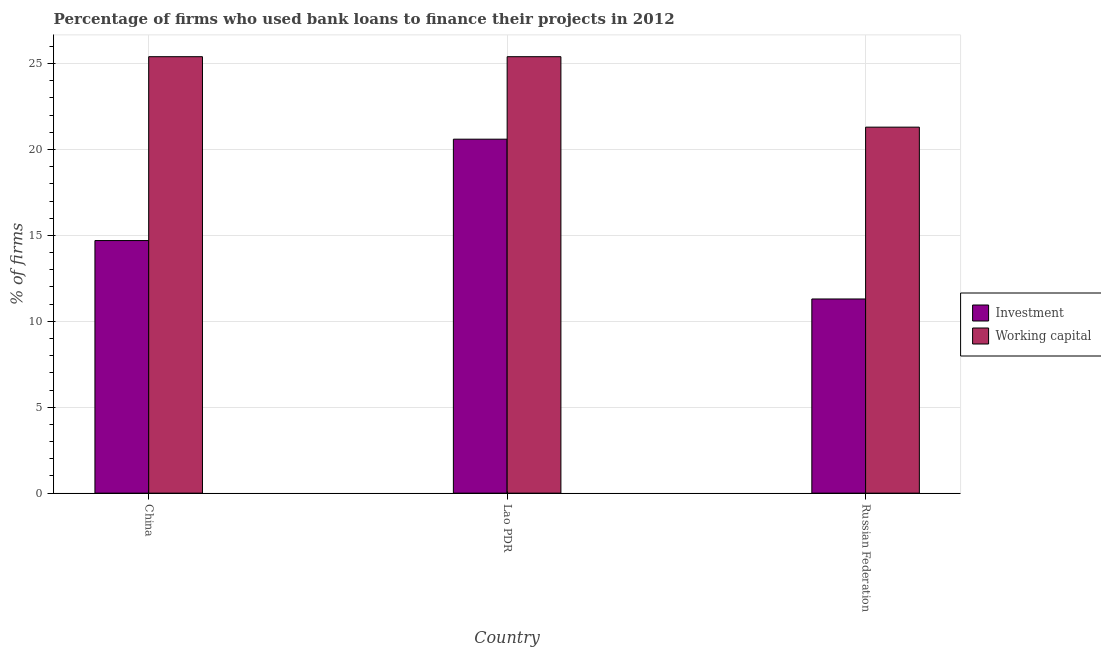How many different coloured bars are there?
Provide a short and direct response. 2. How many groups of bars are there?
Give a very brief answer. 3. Are the number of bars on each tick of the X-axis equal?
Your response must be concise. Yes. How many bars are there on the 1st tick from the left?
Offer a very short reply. 2. How many bars are there on the 3rd tick from the right?
Give a very brief answer. 2. What is the label of the 1st group of bars from the left?
Provide a succinct answer. China. In how many cases, is the number of bars for a given country not equal to the number of legend labels?
Keep it short and to the point. 0. What is the percentage of firms using banks to finance investment in Lao PDR?
Keep it short and to the point. 20.6. Across all countries, what is the maximum percentage of firms using banks to finance investment?
Offer a very short reply. 20.6. In which country was the percentage of firms using banks to finance working capital minimum?
Your answer should be compact. Russian Federation. What is the total percentage of firms using banks to finance working capital in the graph?
Your answer should be compact. 72.1. What is the difference between the percentage of firms using banks to finance working capital in China and that in Russian Federation?
Make the answer very short. 4.1. What is the difference between the percentage of firms using banks to finance working capital in China and the percentage of firms using banks to finance investment in Russian Federation?
Keep it short and to the point. 14.1. What is the average percentage of firms using banks to finance working capital per country?
Provide a succinct answer. 24.03. What is the difference between the percentage of firms using banks to finance working capital and percentage of firms using banks to finance investment in China?
Ensure brevity in your answer.  10.7. Is the percentage of firms using banks to finance investment in Lao PDR less than that in Russian Federation?
Offer a terse response. No. What is the difference between the highest and the second highest percentage of firms using banks to finance investment?
Offer a very short reply. 5.9. What is the difference between the highest and the lowest percentage of firms using banks to finance working capital?
Your answer should be compact. 4.1. In how many countries, is the percentage of firms using banks to finance working capital greater than the average percentage of firms using banks to finance working capital taken over all countries?
Keep it short and to the point. 2. What does the 1st bar from the left in Lao PDR represents?
Your answer should be compact. Investment. What does the 1st bar from the right in Russian Federation represents?
Provide a succinct answer. Working capital. How many bars are there?
Your response must be concise. 6. Are all the bars in the graph horizontal?
Offer a terse response. No. How many countries are there in the graph?
Give a very brief answer. 3. What is the difference between two consecutive major ticks on the Y-axis?
Your answer should be compact. 5. Are the values on the major ticks of Y-axis written in scientific E-notation?
Make the answer very short. No. Where does the legend appear in the graph?
Offer a terse response. Center right. How many legend labels are there?
Your answer should be very brief. 2. How are the legend labels stacked?
Provide a short and direct response. Vertical. What is the title of the graph?
Make the answer very short. Percentage of firms who used bank loans to finance their projects in 2012. What is the label or title of the Y-axis?
Provide a succinct answer. % of firms. What is the % of firms in Working capital in China?
Give a very brief answer. 25.4. What is the % of firms in Investment in Lao PDR?
Provide a short and direct response. 20.6. What is the % of firms of Working capital in Lao PDR?
Offer a very short reply. 25.4. What is the % of firms in Investment in Russian Federation?
Provide a succinct answer. 11.3. What is the % of firms of Working capital in Russian Federation?
Provide a succinct answer. 21.3. Across all countries, what is the maximum % of firms of Investment?
Give a very brief answer. 20.6. Across all countries, what is the maximum % of firms of Working capital?
Offer a very short reply. 25.4. Across all countries, what is the minimum % of firms in Working capital?
Provide a succinct answer. 21.3. What is the total % of firms in Investment in the graph?
Ensure brevity in your answer.  46.6. What is the total % of firms of Working capital in the graph?
Offer a very short reply. 72.1. What is the difference between the % of firms of Investment in Lao PDR and that in Russian Federation?
Offer a terse response. 9.3. What is the difference between the % of firms of Working capital in Lao PDR and that in Russian Federation?
Provide a succinct answer. 4.1. What is the difference between the % of firms in Investment in China and the % of firms in Working capital in Russian Federation?
Offer a very short reply. -6.6. What is the average % of firms in Investment per country?
Offer a very short reply. 15.53. What is the average % of firms in Working capital per country?
Your answer should be very brief. 24.03. What is the difference between the % of firms of Investment and % of firms of Working capital in Lao PDR?
Your response must be concise. -4.8. What is the ratio of the % of firms in Investment in China to that in Lao PDR?
Provide a succinct answer. 0.71. What is the ratio of the % of firms of Working capital in China to that in Lao PDR?
Offer a terse response. 1. What is the ratio of the % of firms in Investment in China to that in Russian Federation?
Make the answer very short. 1.3. What is the ratio of the % of firms in Working capital in China to that in Russian Federation?
Your response must be concise. 1.19. What is the ratio of the % of firms in Investment in Lao PDR to that in Russian Federation?
Ensure brevity in your answer.  1.82. What is the ratio of the % of firms of Working capital in Lao PDR to that in Russian Federation?
Make the answer very short. 1.19. What is the difference between the highest and the second highest % of firms in Investment?
Your response must be concise. 5.9. 